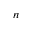Convert formula to latex. <formula><loc_0><loc_0><loc_500><loc_500>n</formula> 